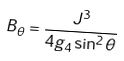<formula> <loc_0><loc_0><loc_500><loc_500>B _ { \theta } = \frac { J ^ { 3 } } { 4 g _ { 4 } \sin ^ { 2 } \theta }</formula> 